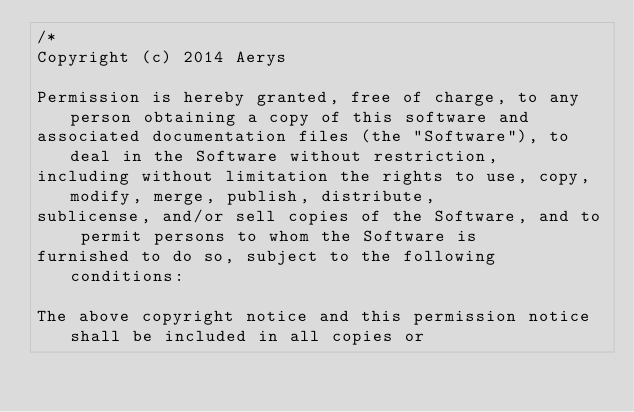<code> <loc_0><loc_0><loc_500><loc_500><_C++_>/*
Copyright (c) 2014 Aerys

Permission is hereby granted, free of charge, to any person obtaining a copy of this software and
associated documentation files (the "Software"), to deal in the Software without restriction,
including without limitation the rights to use, copy, modify, merge, publish, distribute,
sublicense, and/or sell copies of the Software, and to permit persons to whom the Software is
furnished to do so, subject to the following conditions:

The above copyright notice and this permission notice shall be included in all copies or</code> 